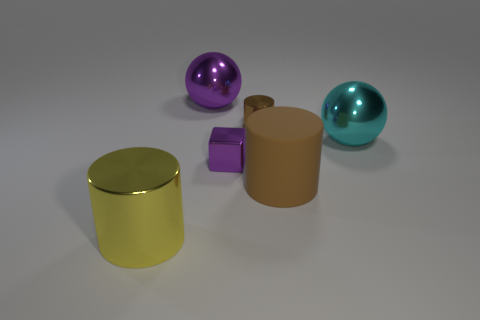Subtract all brown matte cylinders. How many cylinders are left? 2 Subtract all red balls. How many brown cylinders are left? 2 Subtract all yellow cylinders. How many cylinders are left? 2 Add 3 large cylinders. How many objects exist? 9 Subtract 0 yellow balls. How many objects are left? 6 Subtract all blocks. How many objects are left? 5 Subtract all gray balls. Subtract all red cylinders. How many balls are left? 2 Subtract all large matte objects. Subtract all small cylinders. How many objects are left? 4 Add 3 large brown matte cylinders. How many large brown matte cylinders are left? 4 Add 1 purple rubber cubes. How many purple rubber cubes exist? 1 